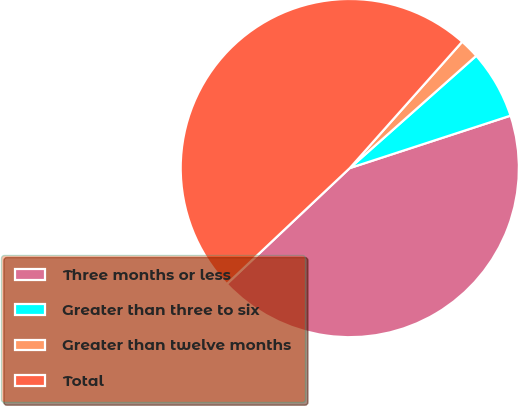Convert chart. <chart><loc_0><loc_0><loc_500><loc_500><pie_chart><fcel>Three months or less<fcel>Greater than three to six<fcel>Greater than twelve months<fcel>Total<nl><fcel>42.99%<fcel>6.54%<fcel>1.87%<fcel>48.6%<nl></chart> 